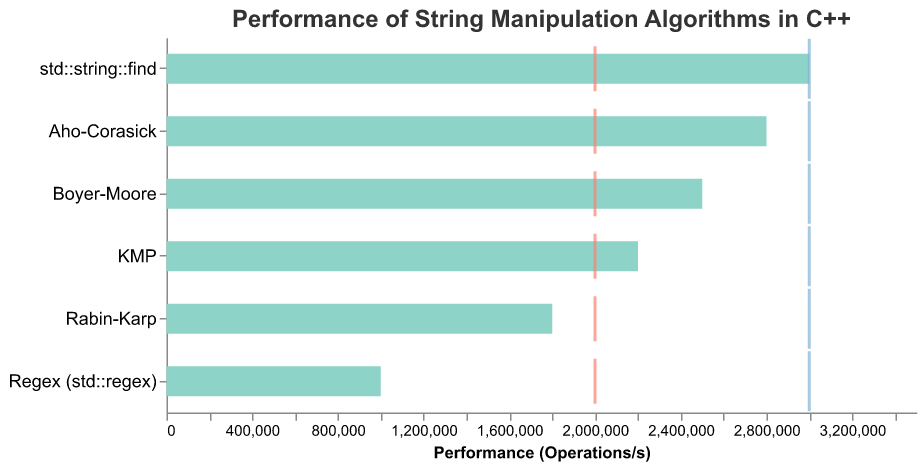What is the performance of the Boyer-Moore algorithm? The performance of the Boyer-Moore algorithm is depicted by the length of its bar in the plot, which is labeled in the x-axis in terms of operations per second.
Answer: 2,500,000 operations/s How many algorithms meet or exceed the benchmark performance of 2,000,000 operations per second? By looking at the bars and their corresponding lengths, we can see which algorithms surpass the benchmark line labeled as "Benchmark" at 2,000,000 operations per second. The algorithms are Boyer-Moore, KMP, std::string::find, and Aho-Corasick.
Answer: 4 algorithms Which algorithm has the lowest performance, and what is it? By examining the shortest bar on the chart, we can determine that the Regex (std::regex) algorithm has the lowest performance. Its performance is listed on the x-axis.
Answer: Regex (std::regex), 1,000,000 operations/s How much does the performance of std::string::find exceed its benchmark? The performance of std::string::find is 3,000,000 operations per second while the benchmark is 2,000,000 operations per second. The difference can be calculated by subtracting the benchmark from the performance.
Answer: 1,000,000 operations/s Which algorithm comes closest to the target performance without exceeding it? By comparing the performance bars to the target ticks, we can see that Aho-Corasick is closest to the target of 3,000,000 operations per second but does not exceed it, with a performance of 2,800,000 operations per second.
Answer: Aho-Corasick Between Boyer-Moore and KMP, which algorithm performs better and by how much? By comparing the length of the bars for Boyer-Moore and KMP, we see that Boyer-Moore performs at 2,500,000 operations per second while KMP performs at 2,200,000 operations per second. The difference is obtained by subtracting KMP's performance from Boyer-Moore's performance.
Answer: Boyer-Moore, 300,000 operations/s What are the benchmark and target values in the chart? The values of the benchmark and target lines are visual sensory elements on the chart. They are clearly labeled on the x-axis for multiple algorithms. The benchmark is labeled at 2,000,000 operations per second and the target is labeled at 3,000,000 operations per second.
Answer: Benchmark: 2,000,000 operations/s, Target: 3,000,000 operations/s 